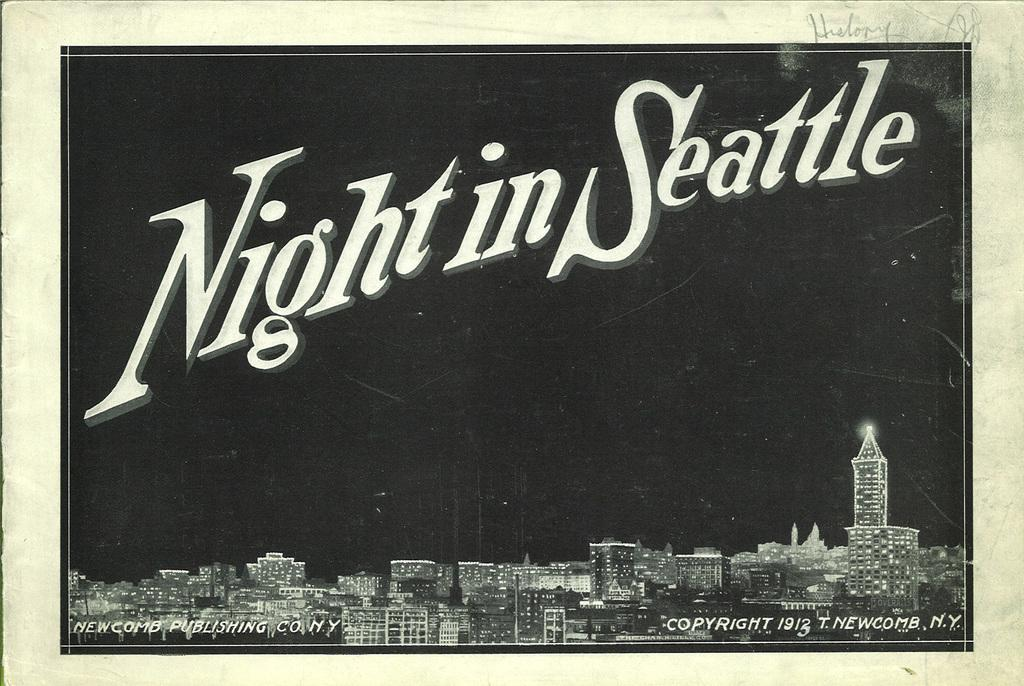What is the main subject of the image? There is a photo in the image. What can be seen in the photo? The photo contains buildings. What additional information is provided on the photo? The text "NIGHT IN SEATTLE" is present on the photo. What type of cheese is being used to support the elbow in the image? There is no cheese or elbow present in the image; it only features a photo with buildings and the text "NIGHT IN SEATTLE." 